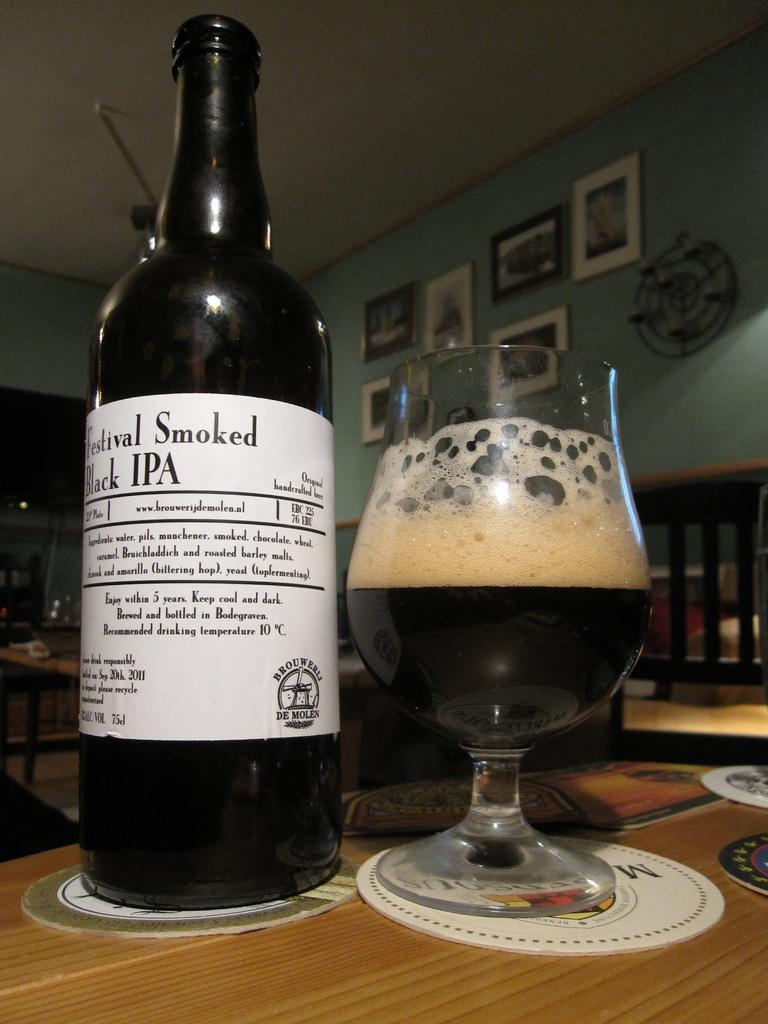<image>
Write a terse but informative summary of the picture. A bottle labeled black IPA is next to a glass. 